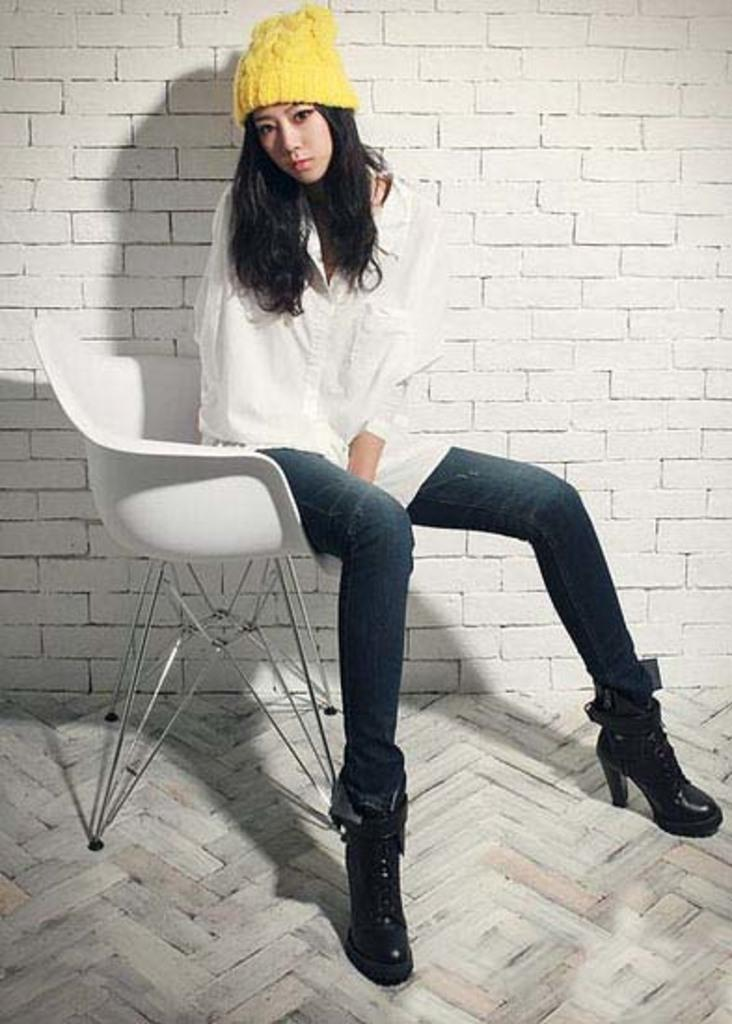What is the woman doing in the image? She is sitting on a chair. What is she wearing on her head? She is wearing a cap. What is on the floor in the image? There is a carpet on the floor. What can be seen on the wall behind her? There is a white color brick wall in the background. Where is the faucet located in the image? There is no faucet present in the image. What type of vegetable is she holding in the image? There is no vegetable visible in the image. 